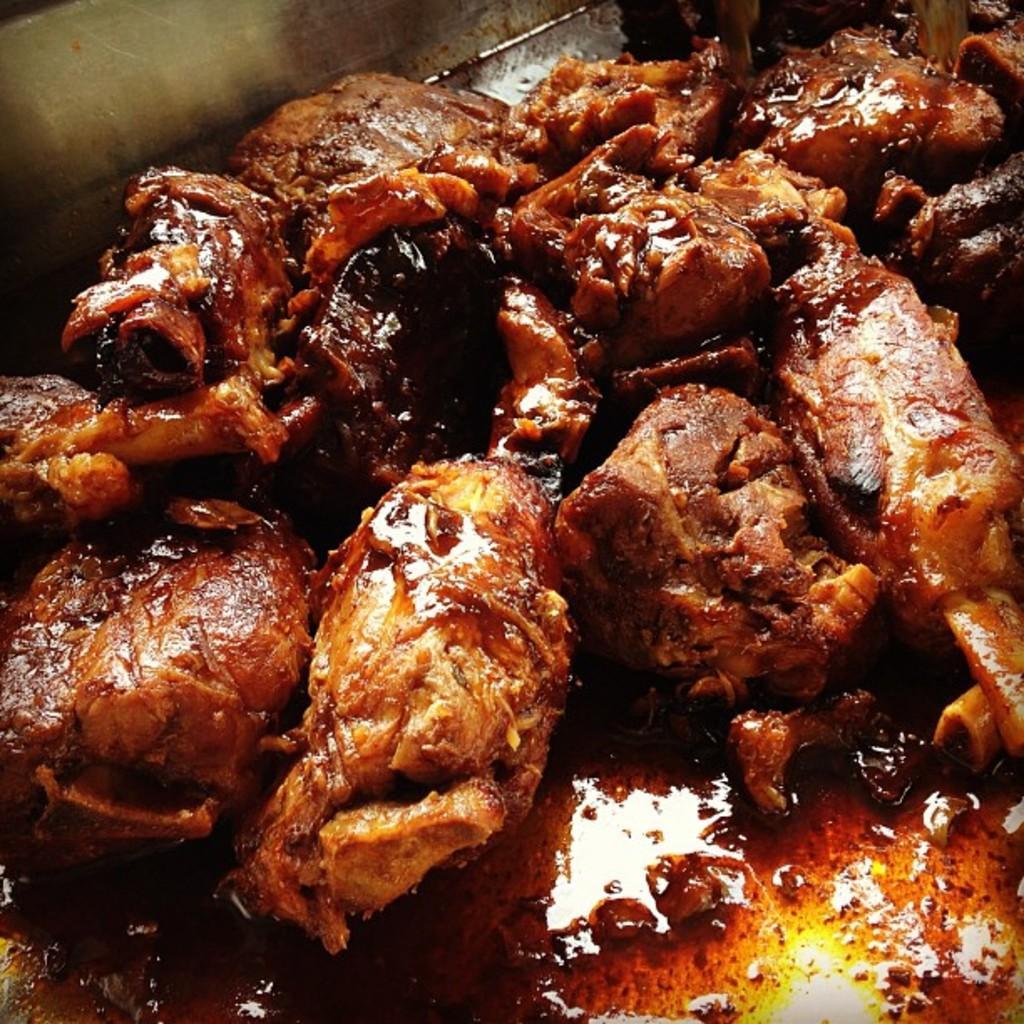How would you summarize this image in a sentence or two? In this picture we can see food in a container. 